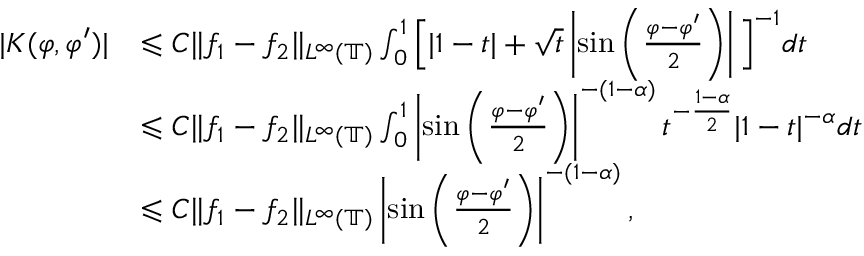<formula> <loc_0><loc_0><loc_500><loc_500>\begin{array} { r l } { | K ( \varphi , \varphi ^ { \prime } ) | } & { \leqslant C \| f _ { 1 } - f _ { 2 } \| _ { L ^ { \infty } ( \mathbb { T } ) } \int _ { 0 } ^ { 1 } \left [ | 1 - t | + \sqrt { t } \left | \sin \left ( \frac { \varphi - \varphi ^ { \prime } } { 2 } \right ) \right | \right ] ^ { - 1 } d t } \\ & { \leqslant C \| f _ { 1 } - f _ { 2 } \| _ { L ^ { \infty } ( \mathbb { T } ) } \int _ { 0 } ^ { 1 } \left | \sin \left ( \frac { \varphi - \varphi ^ { \prime } } { 2 } \right ) \right | ^ { - ( 1 - \alpha ) } t ^ { - \frac { 1 - \alpha } { 2 } } | 1 - t | ^ { - \alpha } d t } \\ & { \leqslant C \| f _ { 1 } - f _ { 2 } \| _ { L ^ { \infty } ( \mathbb { T } ) } \left | \sin \left ( \frac { \varphi - \varphi ^ { \prime } } { 2 } \right ) \right | ^ { - ( 1 - \alpha ) } , } \end{array}</formula> 